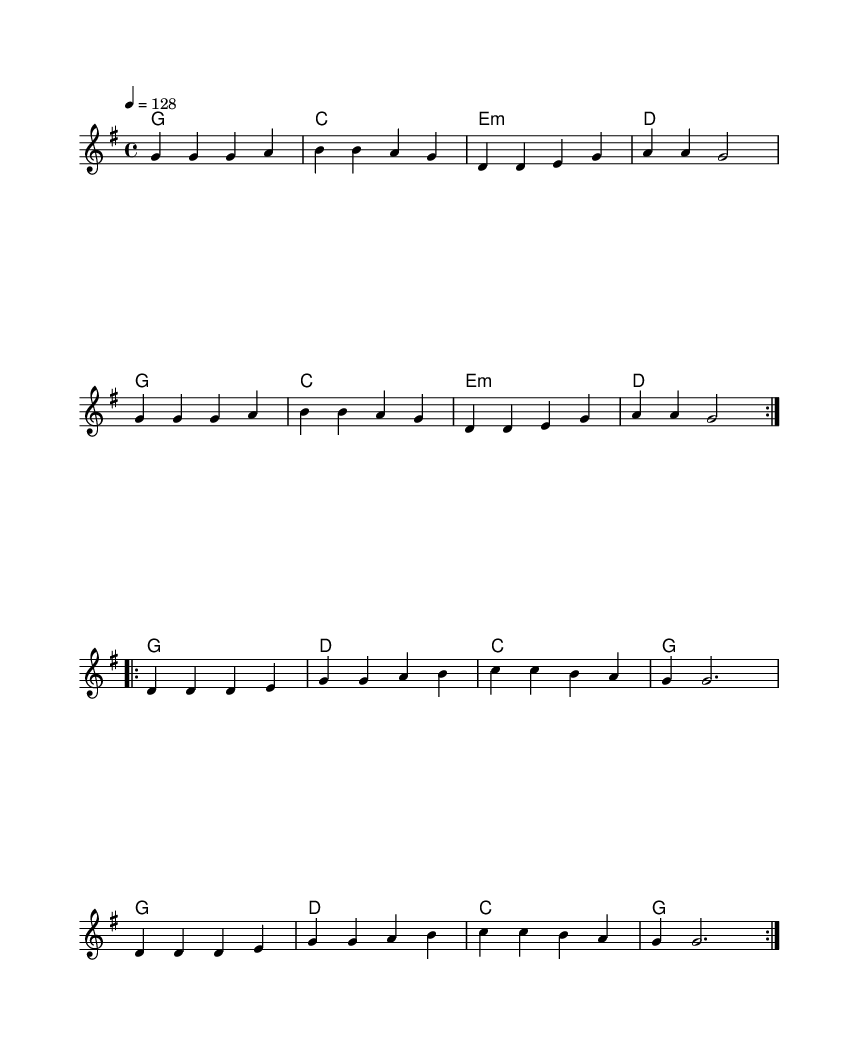What is the key signature of this music? The key signature is G major, indicated by one sharp (F#) at the beginning of the staff.
Answer: G major What is the time signature of the piece? The time signature shown at the beginning of the staff is 4/4, meaning there are four beats in each measure and the quarter note gets one beat.
Answer: 4/4 What is the tempo marking of the song? The tempo marking indicates a speed of 128 beats per minute, shown as "4 = 128" at the beginning of the score.
Answer: 128 How many verses are there in the song? The lyrics indicate two sections of verses, each repeated, as denoted by the volta markings. Each section functions as a verse.
Answer: 2 What chord is played at the beginning of both sections? The first chord in both sections is G major, easily identified by its position in the chord progressions.
Answer: G major What is the lyrical theme of this piece? The lyrics celebrate the courage and heroism of medical professionals involved in mountain rescues, emphasizing their readiness and bravery in life-saving missions.
Answer: Medical heroes How does the structure of this song reflect the characteristics of Country Rock? The song features a common storytelling format with a strong vocal melody, upbeat rhythms, and themes of heroism, typical of the Country Rock genre.
Answer: Upbeat anthems 